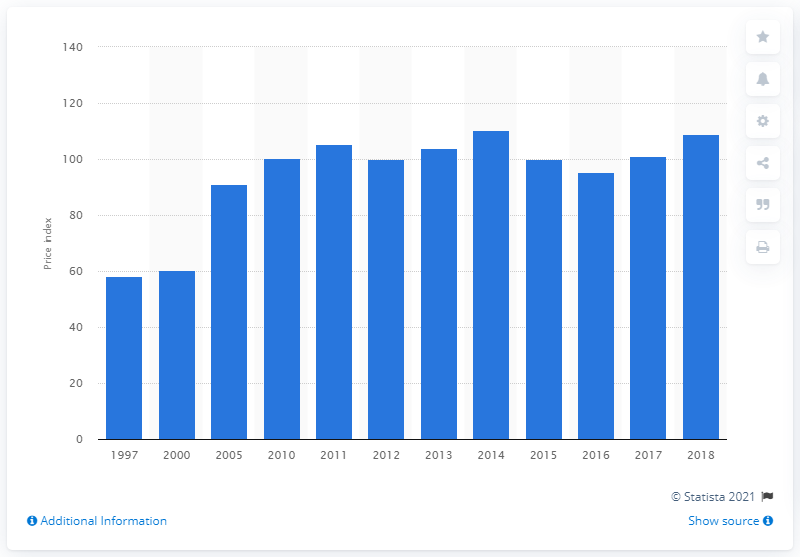Give some essential details in this illustration. In 2018, the energy cost index for fabricated metal product manufacturing was 108.87. 